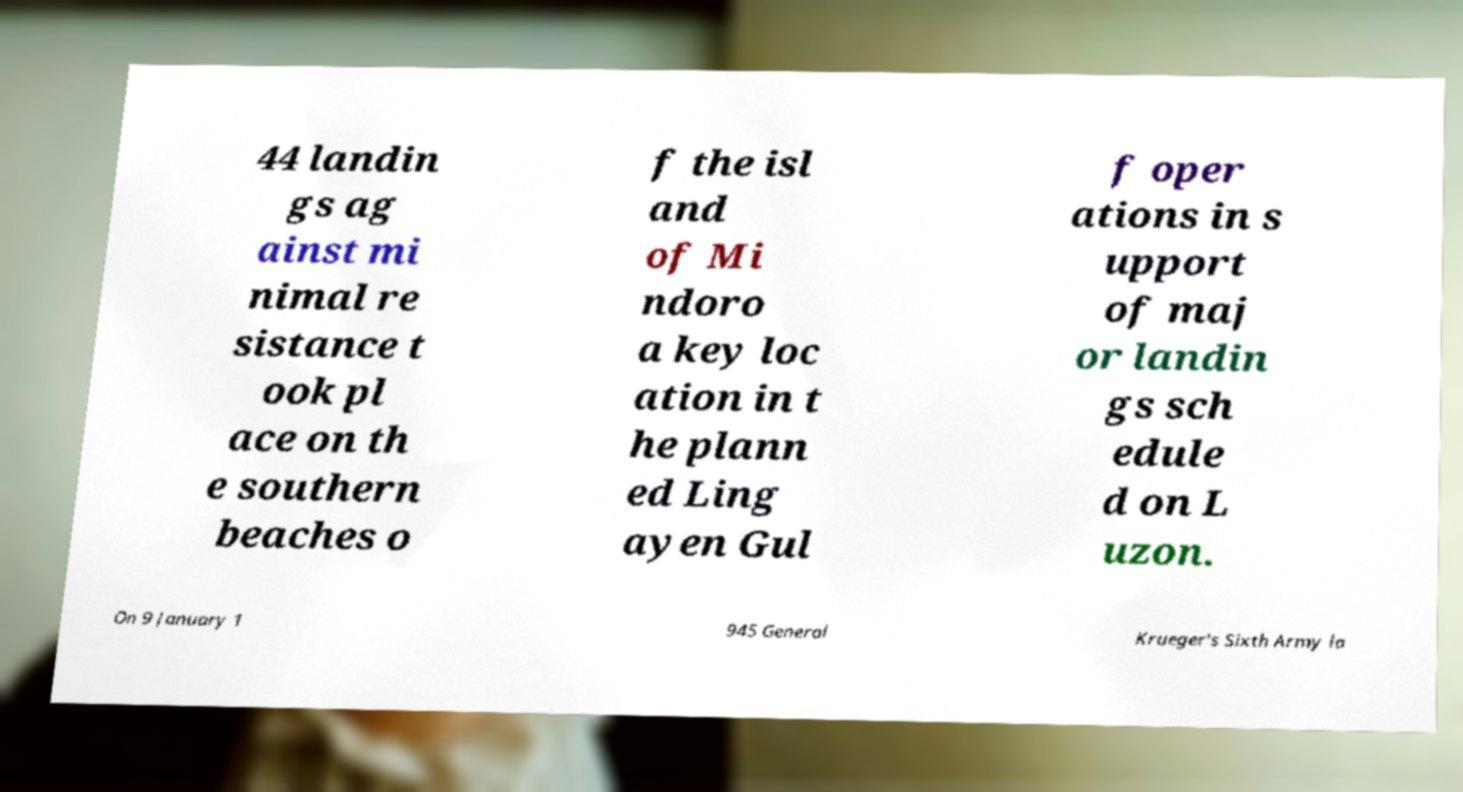Please read and relay the text visible in this image. What does it say? 44 landin gs ag ainst mi nimal re sistance t ook pl ace on th e southern beaches o f the isl and of Mi ndoro a key loc ation in t he plann ed Ling ayen Gul f oper ations in s upport of maj or landin gs sch edule d on L uzon. On 9 January 1 945 General Krueger's Sixth Army la 